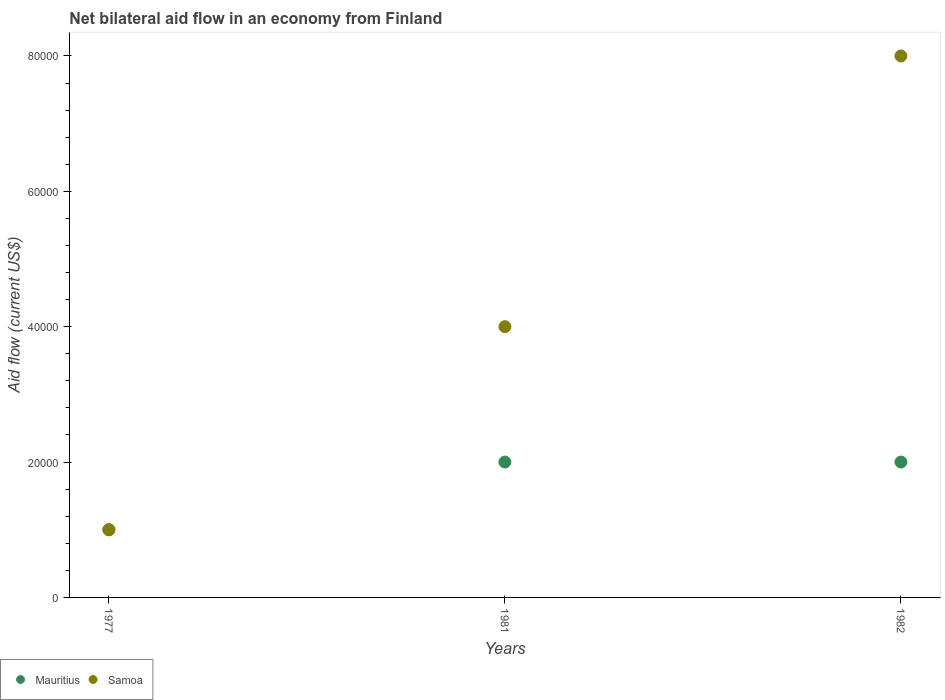What is the net bilateral aid flow in Samoa in 1981?
Ensure brevity in your answer.  4.00e+04. Across all years, what is the maximum net bilateral aid flow in Samoa?
Offer a terse response. 8.00e+04. In which year was the net bilateral aid flow in Samoa minimum?
Provide a succinct answer. 1977. What is the difference between the net bilateral aid flow in Samoa in 1982 and the net bilateral aid flow in Mauritius in 1977?
Ensure brevity in your answer.  7.00e+04. What is the average net bilateral aid flow in Mauritius per year?
Your answer should be compact. 1.67e+04. In how many years, is the net bilateral aid flow in Mauritius greater than 8000 US$?
Ensure brevity in your answer.  3. What is the ratio of the net bilateral aid flow in Mauritius in 1981 to that in 1982?
Keep it short and to the point. 1. Is the net bilateral aid flow in Mauritius in 1977 less than that in 1982?
Your response must be concise. Yes. Is the difference between the net bilateral aid flow in Mauritius in 1977 and 1981 greater than the difference between the net bilateral aid flow in Samoa in 1977 and 1981?
Provide a succinct answer. Yes. Is the net bilateral aid flow in Mauritius strictly greater than the net bilateral aid flow in Samoa over the years?
Offer a very short reply. No. Is the net bilateral aid flow in Mauritius strictly less than the net bilateral aid flow in Samoa over the years?
Your answer should be very brief. No. How many dotlines are there?
Offer a terse response. 2. Are the values on the major ticks of Y-axis written in scientific E-notation?
Your answer should be very brief. No. Does the graph contain any zero values?
Provide a succinct answer. No. Where does the legend appear in the graph?
Make the answer very short. Bottom left. How many legend labels are there?
Offer a very short reply. 2. What is the title of the graph?
Make the answer very short. Net bilateral aid flow in an economy from Finland. Does "Russian Federation" appear as one of the legend labels in the graph?
Give a very brief answer. No. What is the label or title of the X-axis?
Offer a very short reply. Years. What is the label or title of the Y-axis?
Make the answer very short. Aid flow (current US$). What is the Aid flow (current US$) in Mauritius in 1977?
Provide a short and direct response. 10000. What is the Aid flow (current US$) of Samoa in 1977?
Offer a terse response. 10000. What is the Aid flow (current US$) of Mauritius in 1981?
Keep it short and to the point. 2.00e+04. What is the Aid flow (current US$) in Mauritius in 1982?
Offer a very short reply. 2.00e+04. Across all years, what is the maximum Aid flow (current US$) in Mauritius?
Offer a terse response. 2.00e+04. Across all years, what is the maximum Aid flow (current US$) of Samoa?
Offer a very short reply. 8.00e+04. Across all years, what is the minimum Aid flow (current US$) in Mauritius?
Provide a short and direct response. 10000. Across all years, what is the minimum Aid flow (current US$) of Samoa?
Your response must be concise. 10000. What is the total Aid flow (current US$) in Samoa in the graph?
Offer a terse response. 1.30e+05. What is the difference between the Aid flow (current US$) of Mauritius in 1977 and that in 1981?
Your answer should be very brief. -10000. What is the difference between the Aid flow (current US$) of Samoa in 1977 and that in 1982?
Your response must be concise. -7.00e+04. What is the difference between the Aid flow (current US$) of Samoa in 1981 and that in 1982?
Give a very brief answer. -4.00e+04. What is the difference between the Aid flow (current US$) of Mauritius in 1977 and the Aid flow (current US$) of Samoa in 1982?
Your response must be concise. -7.00e+04. What is the difference between the Aid flow (current US$) in Mauritius in 1981 and the Aid flow (current US$) in Samoa in 1982?
Your answer should be very brief. -6.00e+04. What is the average Aid flow (current US$) in Mauritius per year?
Offer a terse response. 1.67e+04. What is the average Aid flow (current US$) of Samoa per year?
Ensure brevity in your answer.  4.33e+04. In the year 1981, what is the difference between the Aid flow (current US$) in Mauritius and Aid flow (current US$) in Samoa?
Provide a succinct answer. -2.00e+04. What is the ratio of the Aid flow (current US$) of Samoa in 1977 to that in 1981?
Ensure brevity in your answer.  0.25. What is the ratio of the Aid flow (current US$) in Mauritius in 1977 to that in 1982?
Give a very brief answer. 0.5. What is the ratio of the Aid flow (current US$) of Samoa in 1977 to that in 1982?
Provide a succinct answer. 0.12. What is the ratio of the Aid flow (current US$) in Samoa in 1981 to that in 1982?
Your response must be concise. 0.5. What is the difference between the highest and the second highest Aid flow (current US$) in Mauritius?
Offer a terse response. 0. What is the difference between the highest and the lowest Aid flow (current US$) in Samoa?
Keep it short and to the point. 7.00e+04. 